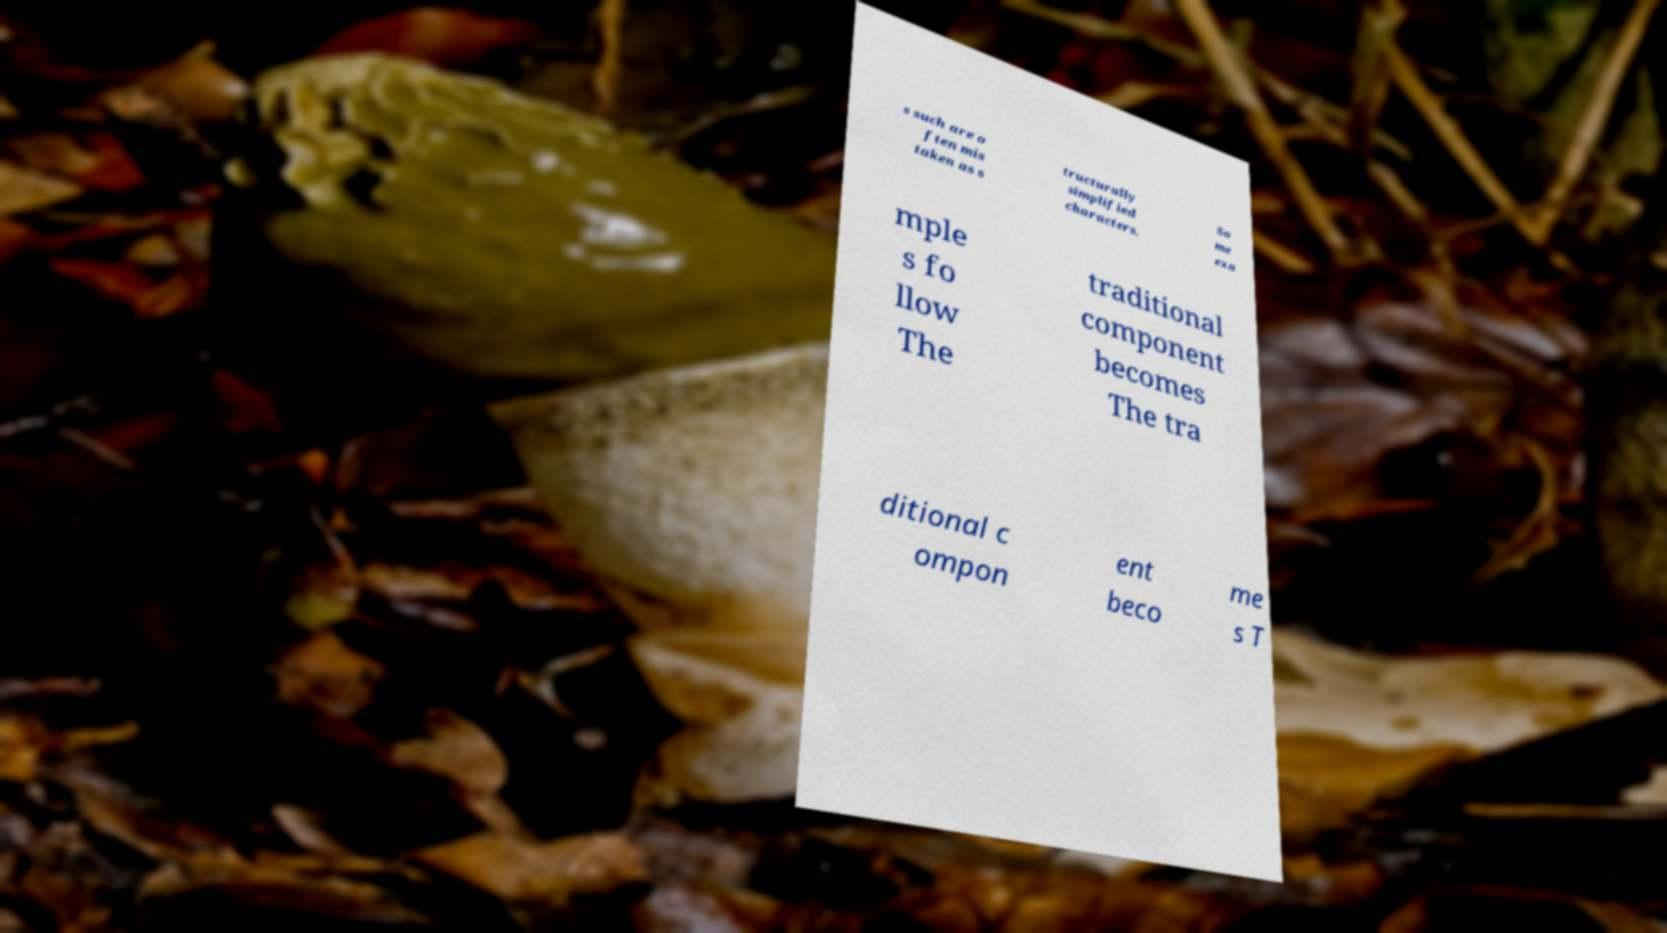For documentation purposes, I need the text within this image transcribed. Could you provide that? s such are o ften mis taken as s tructurally simplified characters. So me exa mple s fo llow The traditional component becomes The tra ditional c ompon ent beco me s T 